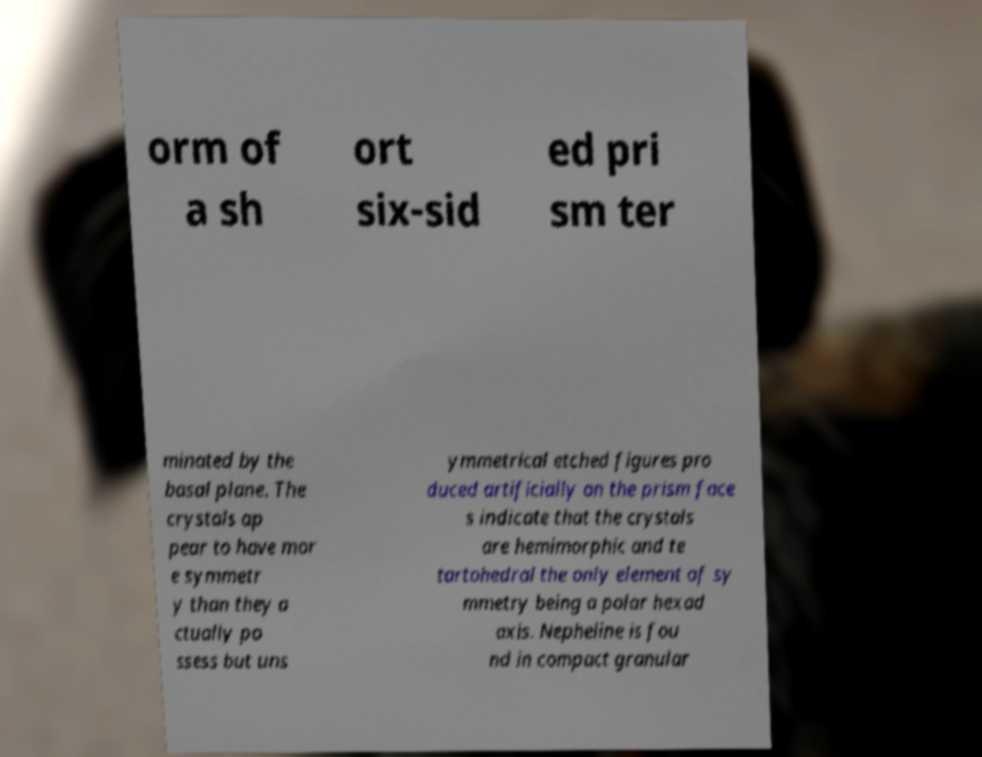Can you accurately transcribe the text from the provided image for me? orm of a sh ort six-sid ed pri sm ter minated by the basal plane. The crystals ap pear to have mor e symmetr y than they a ctually po ssess but uns ymmetrical etched figures pro duced artificially on the prism face s indicate that the crystals are hemimorphic and te tartohedral the only element of sy mmetry being a polar hexad axis. Nepheline is fou nd in compact granular 